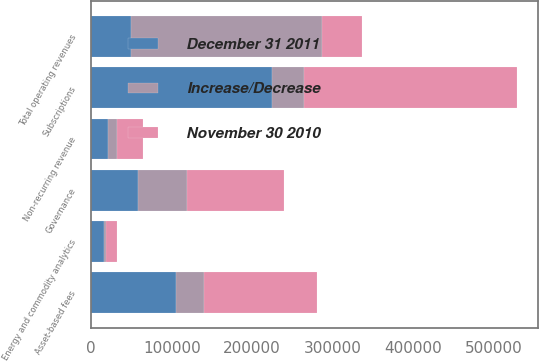<chart> <loc_0><loc_0><loc_500><loc_500><stacked_bar_chart><ecel><fcel>Subscriptions<fcel>Asset-based fees<fcel>Energy and commodity analytics<fcel>Governance<fcel>Total operating revenues<fcel>Non-recurring revenue<nl><fcel>November 30 2010<fcel>264390<fcel>140243<fcel>14263<fcel>119586<fcel>49192<fcel>32487<nl><fcel>December 31 2011<fcel>224600<fcel>105799<fcel>16228<fcel>58594<fcel>49192<fcel>21049<nl><fcel>Increase/Decrease<fcel>39790<fcel>34444<fcel>1965<fcel>60992<fcel>238040<fcel>11438<nl></chart> 